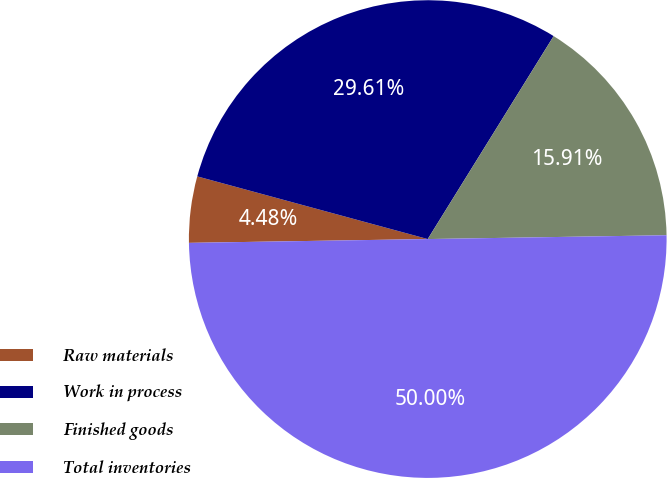Convert chart to OTSL. <chart><loc_0><loc_0><loc_500><loc_500><pie_chart><fcel>Raw materials<fcel>Work in process<fcel>Finished goods<fcel>Total inventories<nl><fcel>4.48%<fcel>29.61%<fcel>15.91%<fcel>50.0%<nl></chart> 